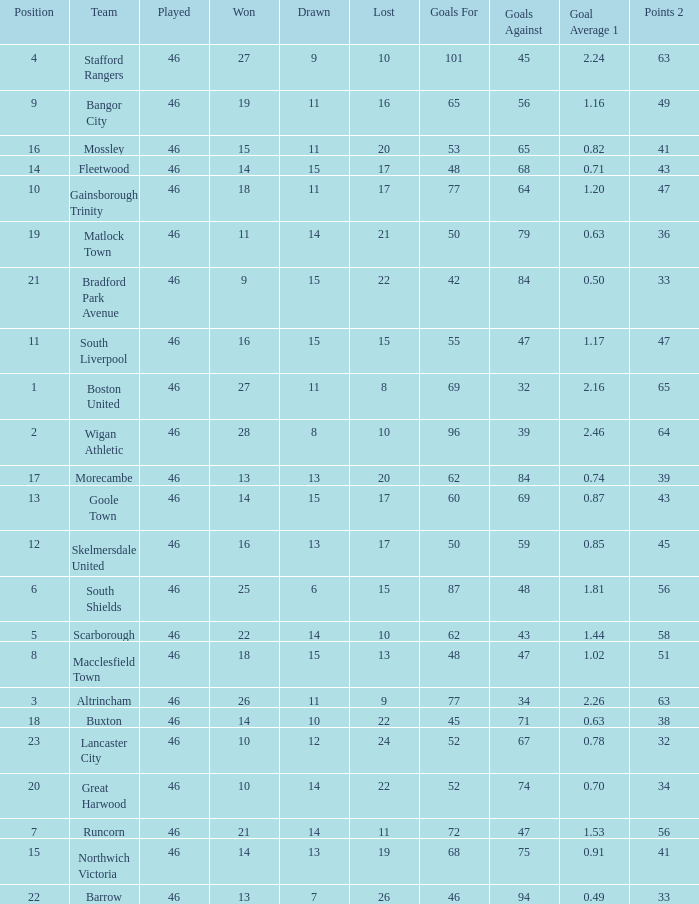How many points did Goole Town accumulate? 1.0. Can you parse all the data within this table? {'header': ['Position', 'Team', 'Played', 'Won', 'Drawn', 'Lost', 'Goals For', 'Goals Against', 'Goal Average 1', 'Points 2'], 'rows': [['4', 'Stafford Rangers', '46', '27', '9', '10', '101', '45', '2.24', '63'], ['9', 'Bangor City', '46', '19', '11', '16', '65', '56', '1.16', '49'], ['16', 'Mossley', '46', '15', '11', '20', '53', '65', '0.82', '41'], ['14', 'Fleetwood', '46', '14', '15', '17', '48', '68', '0.71', '43'], ['10', 'Gainsborough Trinity', '46', '18', '11', '17', '77', '64', '1.20', '47'], ['19', 'Matlock Town', '46', '11', '14', '21', '50', '79', '0.63', '36'], ['21', 'Bradford Park Avenue', '46', '9', '15', '22', '42', '84', '0.50', '33'], ['11', 'South Liverpool', '46', '16', '15', '15', '55', '47', '1.17', '47'], ['1', 'Boston United', '46', '27', '11', '8', '69', '32', '2.16', '65'], ['2', 'Wigan Athletic', '46', '28', '8', '10', '96', '39', '2.46', '64'], ['17', 'Morecambe', '46', '13', '13', '20', '62', '84', '0.74', '39'], ['13', 'Goole Town', '46', '14', '15', '17', '60', '69', '0.87', '43'], ['12', 'Skelmersdale United', '46', '16', '13', '17', '50', '59', '0.85', '45'], ['6', 'South Shields', '46', '25', '6', '15', '87', '48', '1.81', '56'], ['5', 'Scarborough', '46', '22', '14', '10', '62', '43', '1.44', '58'], ['8', 'Macclesfield Town', '46', '18', '15', '13', '48', '47', '1.02', '51'], ['3', 'Altrincham', '46', '26', '11', '9', '77', '34', '2.26', '63'], ['18', 'Buxton', '46', '14', '10', '22', '45', '71', '0.63', '38'], ['23', 'Lancaster City', '46', '10', '12', '24', '52', '67', '0.78', '32'], ['20', 'Great Harwood', '46', '10', '14', '22', '52', '74', '0.70', '34'], ['7', 'Runcorn', '46', '21', '14', '11', '72', '47', '1.53', '56'], ['15', 'Northwich Victoria', '46', '14', '13', '19', '68', '75', '0.91', '41'], ['22', 'Barrow', '46', '13', '7', '26', '46', '94', '0.49', '33']]} 